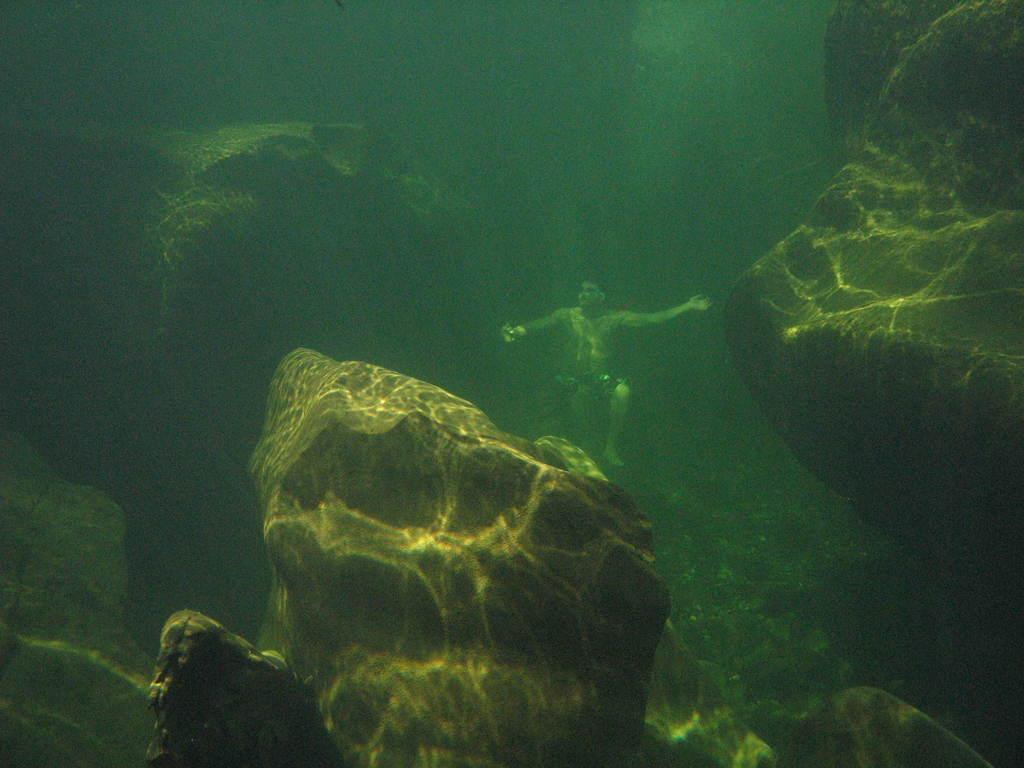Describe this image in one or two sentences. In this image, we can see a person and there are rocks in the water. 